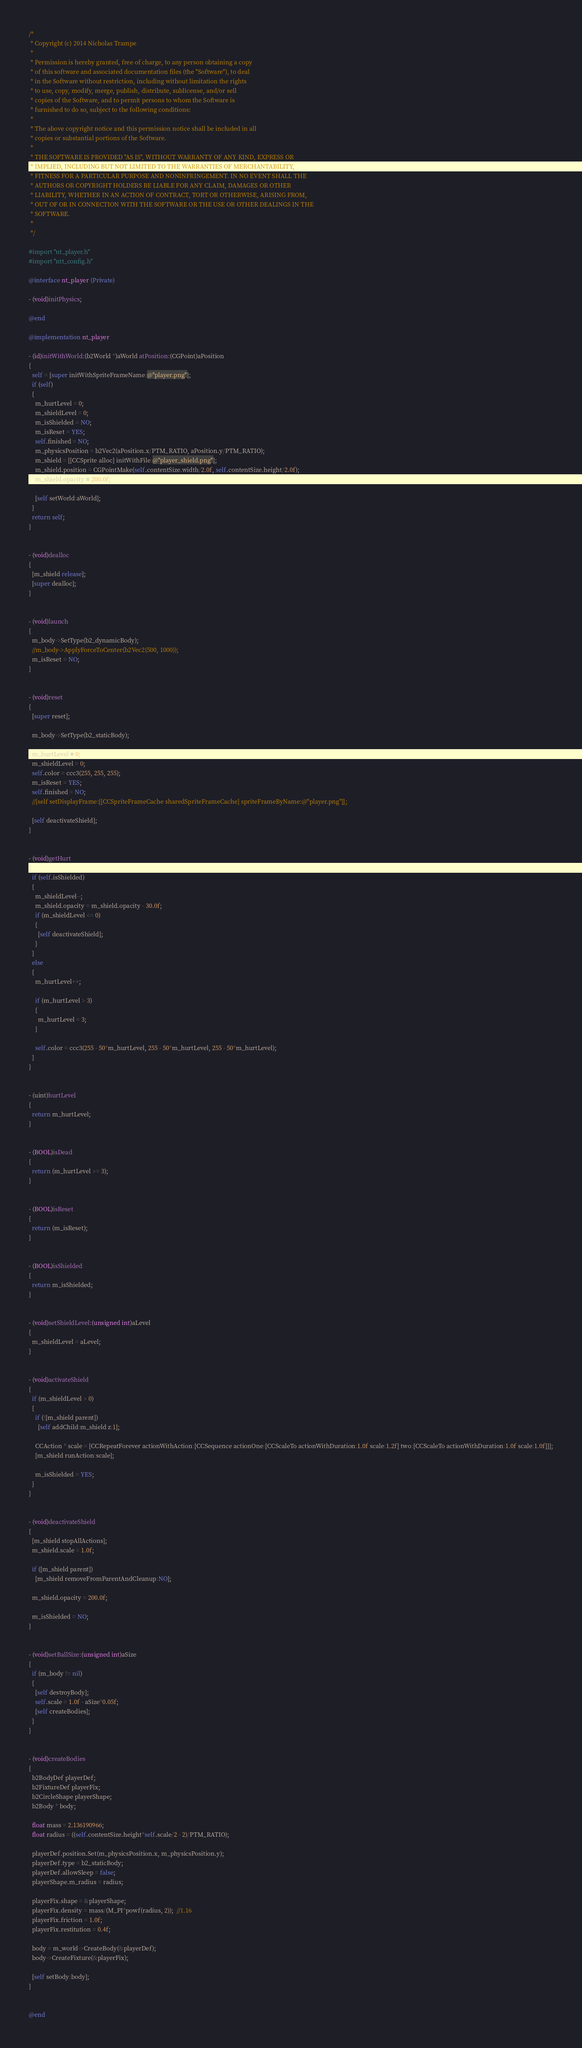<code> <loc_0><loc_0><loc_500><loc_500><_ObjectiveC_>/*
 * Copyright (c) 2014 Nicholas Trampe
 *
 * Permission is hereby granted, free of charge, to any person obtaining a copy
 * of this software and associated documentation files (the "Software"), to deal
 * in the Software without restriction, including without limitation the rights
 * to use, copy, modify, merge, publish, distribute, sublicense, and/or sell
 * copies of the Software, and to permit persons to whom the Software is
 * furnished to do so, subject to the following conditions:
 *
 * The above copyright notice and this permission notice shall be included in all
 * copies or substantial portions of the Software.
 *
 * THE SOFTWARE IS PROVIDED "AS IS", WITHOUT WARRANTY OF ANY KIND, EXPRESS OR
 * IMPLIED, INCLUDING BUT NOT LIMITED TO THE WARRANTIES OF MERCHANTABILITY,
 * FITNESS FOR A PARTICULAR PURPOSE AND NONINFRINGEMENT. IN NO EVENT SHALL THE
 * AUTHORS OR COPYRIGHT HOLDERS BE LIABLE FOR ANY CLAIM, DAMAGES OR OTHER
 * LIABILITY, WHETHER IN AN ACTION OF CONTRACT, TORT OR OTHERWISE, ARISING FROM,
 * OUT OF OR IN CONNECTION WITH THE SOFTWARE OR THE USE OR OTHER DEALINGS IN THE
 * SOFTWARE.
 *
 */

#import "nt_player.h"
#import "ntt_config.h"

@interface nt_player (Private)

- (void)initPhysics;

@end

@implementation nt_player

- (id)initWithWorld:(b2World *)aWorld atPosition:(CGPoint)aPosition
{
  self = [super initWithSpriteFrameName:@"player.png"];
  if (self) 
  {
    m_hurtLevel = 0;
    m_shieldLevel = 0;
    m_isShielded = NO;
    m_isReset = YES;
    self.finished = NO;
    m_physicsPosition = b2Vec2(aPosition.x/PTM_RATIO, aPosition.y/PTM_RATIO);
    m_shield = [[CCSprite alloc] initWithFile:@"player_shield.png"];
    m_shield.position = CGPointMake(self.contentSize.width/2.0f, self.contentSize.height/2.0f);
    m_shield.opacity = 200.0f;
    
    [self setWorld:aWorld];
  }
  return self;
}


- (void)dealloc
{
  [m_shield release];
  [super dealloc];
}


- (void)launch
{
  m_body->SetType(b2_dynamicBody);
  //m_body->ApplyForceToCenter(b2Vec2(500, 1000));
  m_isReset = NO;
}


- (void)reset
{
  [super reset];
  
  m_body->SetType(b2_staticBody);
  
  m_hurtLevel = 0;
  m_shieldLevel = 0;
  self.color = ccc3(255, 255, 255);
  m_isReset = YES;
  self.finished = NO;
  //[self setDisplayFrame:[[CCSpriteFrameCache sharedSpriteFrameCache] spriteFrameByName:@"player.png"]];
  
  [self deactivateShield];
}


- (void)getHurt
{
  if (self.isShielded)
  {
    m_shieldLevel--;
    m_shield.opacity = m_shield.opacity - 30.0f;
    if (m_shieldLevel <= 0)
    {
      [self deactivateShield];
    }
  }
  else
  {
    m_hurtLevel++;
    
    if (m_hurtLevel > 3)
    {
      m_hurtLevel = 3;
    }
    
    self.color = ccc3(255 - 50*m_hurtLevel, 255 - 50*m_hurtLevel, 255 - 50*m_hurtLevel);
  }
}


- (uint)hurtLevel
{
  return m_hurtLevel;
}


- (BOOL)isDead
{
  return (m_hurtLevel >= 3);
}


- (BOOL)isReset
{
  return (m_isReset);
}


- (BOOL)isShielded
{
  return m_isShielded;
}


- (void)setShieldLevel:(unsigned int)aLevel
{
  m_shieldLevel = aLevel;
}


- (void)activateShield
{
  if (m_shieldLevel > 0)
  {
    if (![m_shield parent])
      [self addChild:m_shield z:1];
    
    CCAction * scale = [CCRepeatForever actionWithAction:[CCSequence actionOne:[CCScaleTo actionWithDuration:1.0f scale:1.2f] two:[CCScaleTo actionWithDuration:1.0f scale:1.0f]]];
    [m_shield runAction:scale];
    
    m_isShielded = YES;
  }
}


- (void)deactivateShield
{
  [m_shield stopAllActions];
  m_shield.scale = 1.0f;
  
  if ([m_shield parent])
    [m_shield removeFromParentAndCleanup:NO];
  
  m_shield.opacity = 200.0f;
  
  m_isShielded = NO;
}


- (void)setBallSize:(unsigned int)aSize
{
  if (m_body != nil)
  {
    [self destroyBody];
    self.scale = 1.0f - aSize*0.05f;
    [self createBodies];
  }
}


- (void)createBodies
{
  b2BodyDef playerDef;
  b2FixtureDef playerFix;
  b2CircleShape playerShape;
  b2Body * body;
  
  float mass = 2.136190966;
  float radius = ((self.contentSize.height*self.scale/2 - 2)/PTM_RATIO);
  
  playerDef.position.Set(m_physicsPosition.x, m_physicsPosition.y);
  playerDef.type = b2_staticBody;
  playerDef.allowSleep = false;
  playerShape.m_radius = radius;
  
  playerFix.shape = &playerShape;
  playerFix.density = mass/(M_PI*powf(radius, 2));  //1.16
  playerFix.friction = 1.0f;
  playerFix.restitution = 0.4f;
  
  body = m_world->CreateBody(&playerDef);
  body->CreateFixture(&playerFix);
  
  [self setBody:body];
}


@end
</code> 